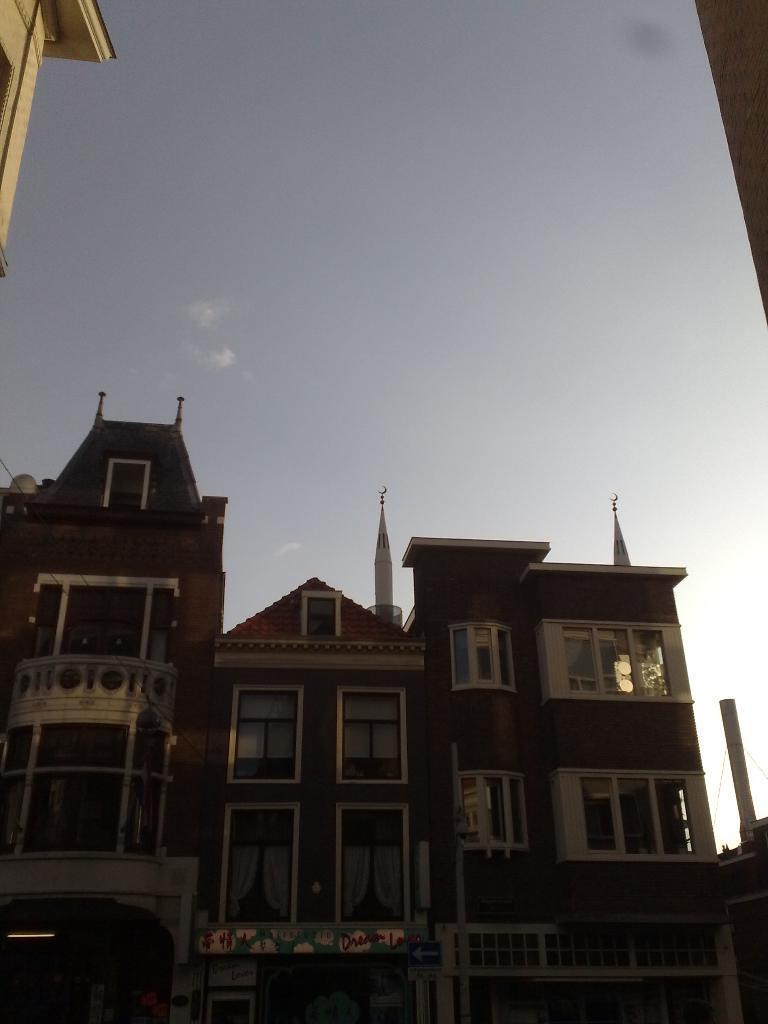Describe this image in one or two sentences. This image consists of a building along with windows and doors. The building is in brown color. To the top, there is sky. 